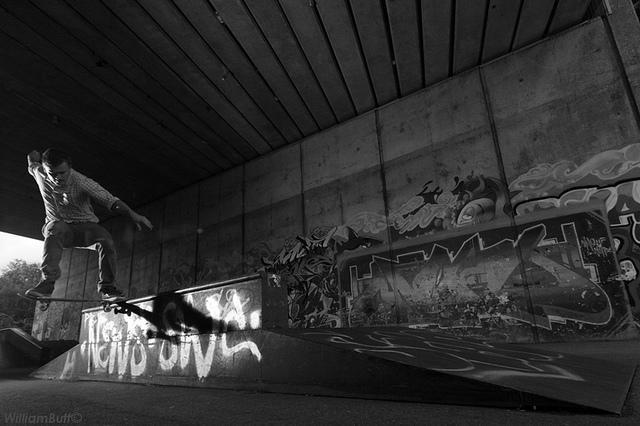How many skateboards are in this scene?
Give a very brief answer. 1. How many cars are to the right?
Give a very brief answer. 0. 